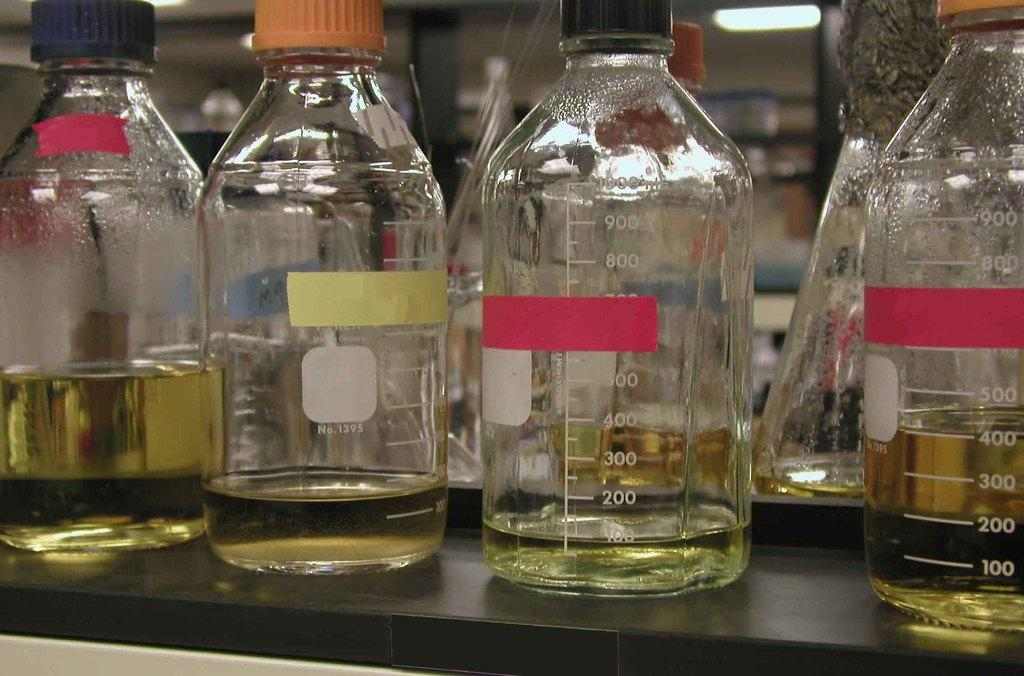<image>
Relay a brief, clear account of the picture shown. Several glass bottles containing yellow liquid and one says No. 1395 